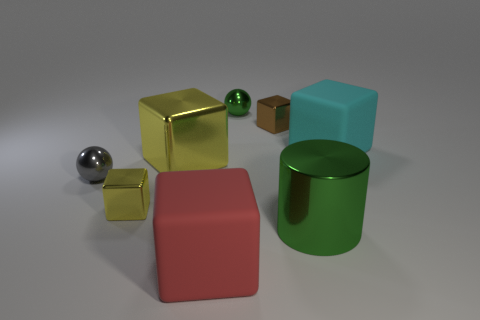Is the number of cyan rubber things that are behind the large yellow metallic object the same as the number of brown metal things that are on the left side of the gray metallic object? Upon examining the image, it is apparent that there are two cyan rubber-looking cubes behind the large yellow metallic cube. On the left side of the gray metallic cylinder, there is only one brown metallic cube. Therefore, the numbers are not equal. 